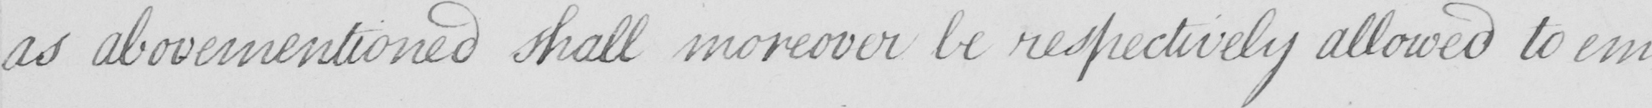Please transcribe the handwritten text in this image. as abovementioned shall moreover be respectively allowed to em- 